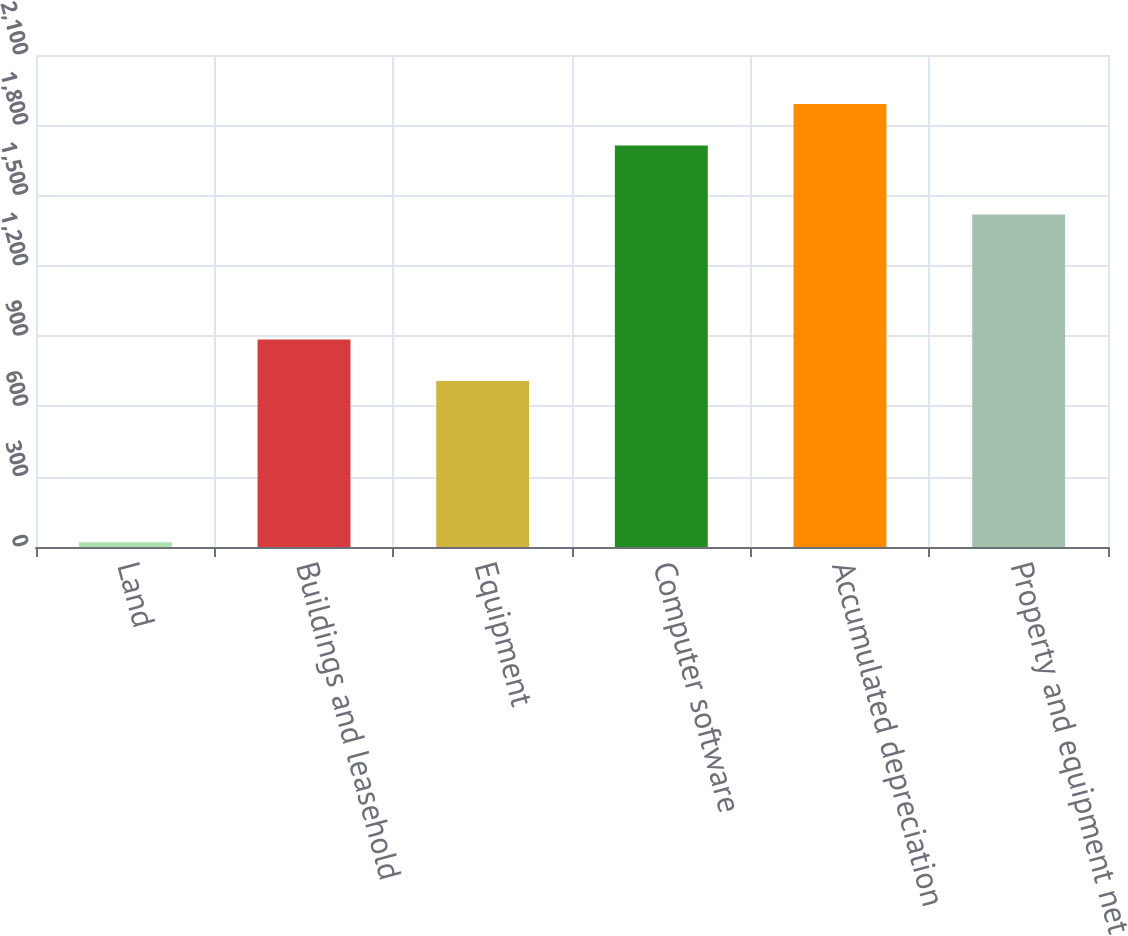Convert chart. <chart><loc_0><loc_0><loc_500><loc_500><bar_chart><fcel>Land<fcel>Buildings and leasehold<fcel>Equipment<fcel>Computer software<fcel>Accumulated depreciation<fcel>Property and equipment net<nl><fcel>20<fcel>885.7<fcel>709<fcel>1714<fcel>1890.7<fcel>1419<nl></chart> 